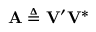Convert formula to latex. <formula><loc_0><loc_0><loc_500><loc_500>A \triangle q V ^ { \prime } V ^ { * }</formula> 